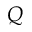<formula> <loc_0><loc_0><loc_500><loc_500>Q</formula> 